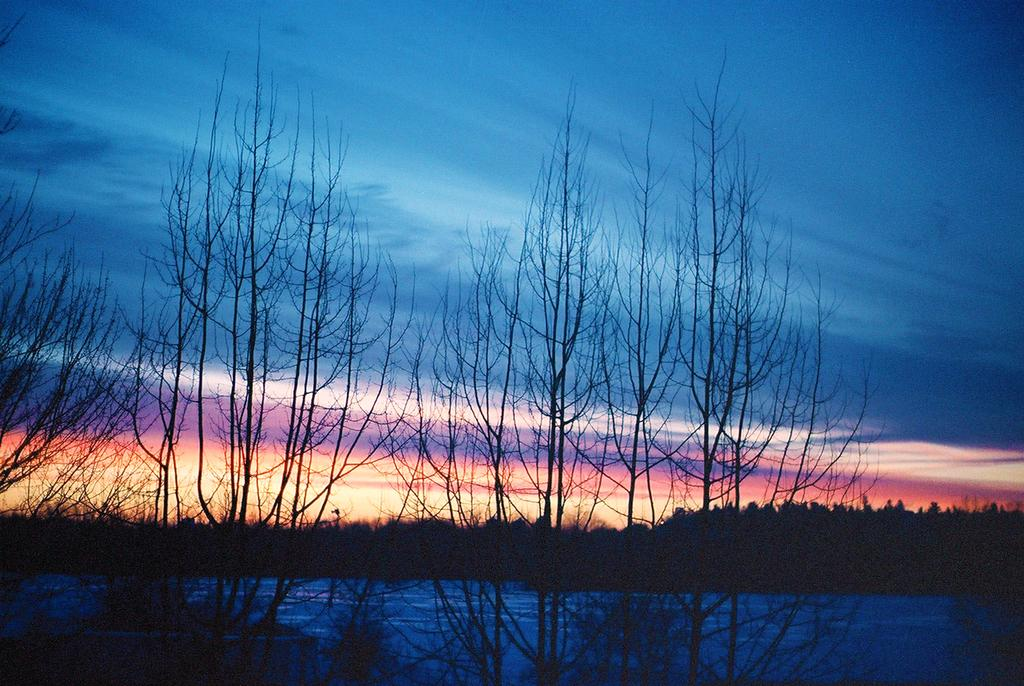What type of vegetation can be seen in the image? There are trees in the image. What is visible at the bottom of the image? There is a surface of water present at the bottom of the image. What is the condition of the sky in the background? The sky in the background is cloudy. What type of soup is being served in the image? There is no soup present in the image; it features trees, water, and a cloudy sky. Can you tell me where the toy is located in the image? There is no toy present in the image. 